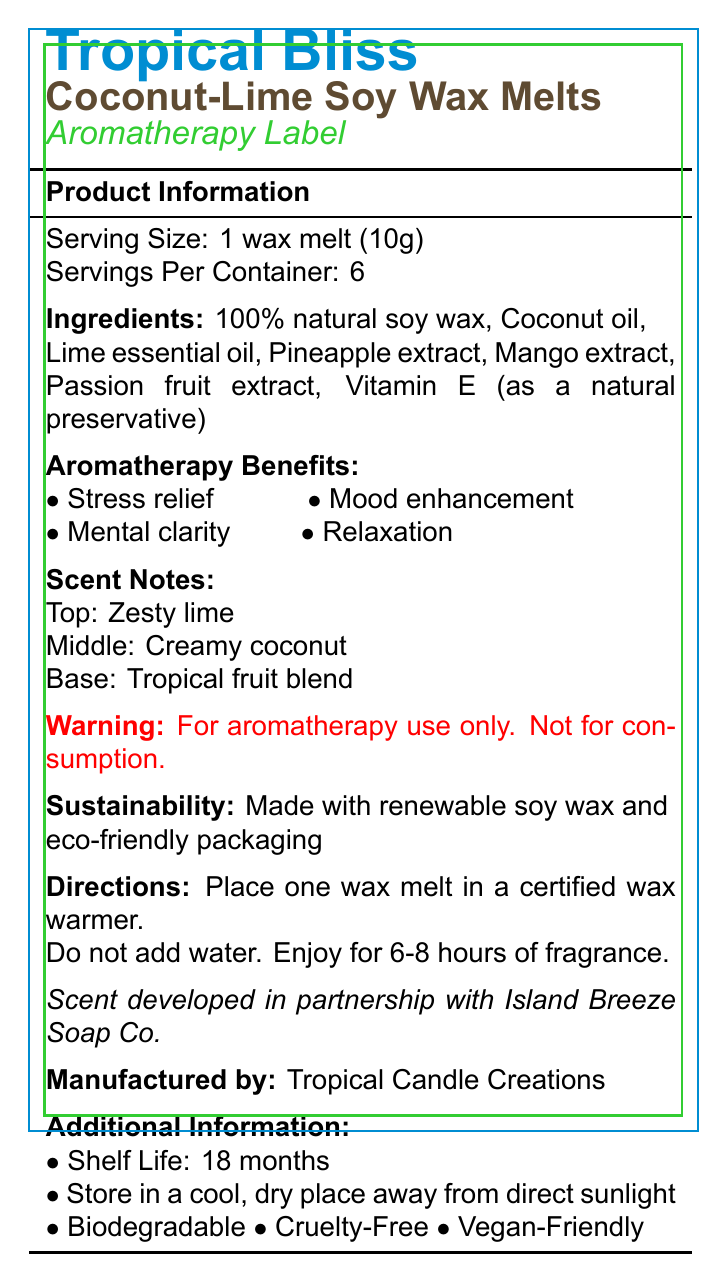what is the serving size? The document lists the serving size under the "Product Information" section as "1 wax melt (10g)".
Answer: 1 wax melt (10g) how many servings are in each container? The "Product Information" section states that there are 6 servings per container.
Answer: 6 name three ingredients in the Tropical Bliss Coconut-Lime Soy Wax Melts. The ingredients are listed under the "Ingredients" section and include 100% natural soy wax, Coconut oil, Lime essential oil among others.
Answer: 100% natural soy wax, Coconut oil, Lime essential oil what are the top, middle, and base notes of the scent? The "Scent Notes" section details the top, middle, and base notes.
Answer: Top: Zesty lime, Middle: Creamy coconut, Base: Tropical fruit blend what is one of the aromatherapy benefits of this product? The document lists "Stress relief" as one of the aromatherapy benefits under the "Aromatherapy Benefits" section.
Answer: Stress relief what is the shelf life of this product? The "Additional Information" section states that the shelf life of the product is 18 months.
Answer: 18 months does the product have any environmental certifications or benefits? The product is described as "Made with renewable soy wax and eco-friendly packaging" under the "Sustainability" section.
Answer: Yes how long does one wax melt provide fragrance? A. 2-4 hours B. 4-6 hours C. 6-8 hours D. 8-10 hours The directions state that each wax melt can provide fragrance for 6-8 hours.
Answer: C. 6-8 hours how should the wax melts be stored? A. In a refrigerator B. In direct sunlight C. In a cool, dry place away from direct sunlight D. In a humid environment The "Additional Information" section advises storing the wax melts in a cool, dry place away from direct sunlight.
Answer: C. In a cool, dry place away from direct sunlight who collaborated in developing the scent? The collaboration note states that the scent was developed in partnership with Island Breeze Soap Co.
Answer: Island Breeze Soap Co. are the Tropical Bliss Coconut-Lime Soy Wax Melts cruelty-free? The product is described as cruelty-free in the "Additional Information" section.
Answer: Yes is it safe to consume the wax melts? The warning statement clearly mentions that the product is for aromatherapy use only and not for consumption.
Answer: No describe the main idea of the document. The main idea of the document is to inform consumers about the Tropical Bliss Coconut-Lime Soy Wax Melts, their ingredients, benefits, and proper usage, while also emphasizing the product's eco-friendly and ethical attributes.
Answer: The document provides detailed information about the Tropical Bliss Coconut-Lime Soy Wax Melts, including serving size, ingredients, aromatherapy benefits, scent notes, directions for use, sustainability information, and additional product attributes like being biodegradable, cruelty-free, and vegan-friendly. It also highlights the collaboration with Island Breeze Soap Co. and includes a warning against consumption. what are the nutritional values of this product? The document does not provide any nutritional information, as it is focused on the candle's scent and usage details rather than nutritional values.
Answer: Cannot be determined 